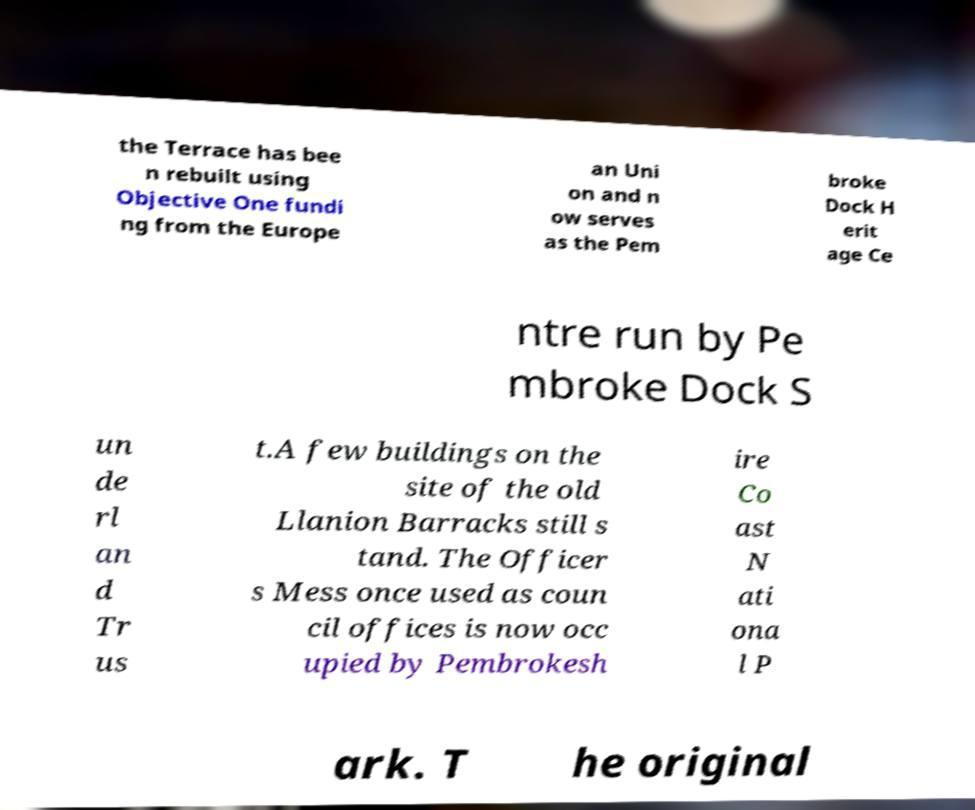I need the written content from this picture converted into text. Can you do that? the Terrace has bee n rebuilt using Objective One fundi ng from the Europe an Uni on and n ow serves as the Pem broke Dock H erit age Ce ntre run by Pe mbroke Dock S un de rl an d Tr us t.A few buildings on the site of the old Llanion Barracks still s tand. The Officer s Mess once used as coun cil offices is now occ upied by Pembrokesh ire Co ast N ati ona l P ark. T he original 